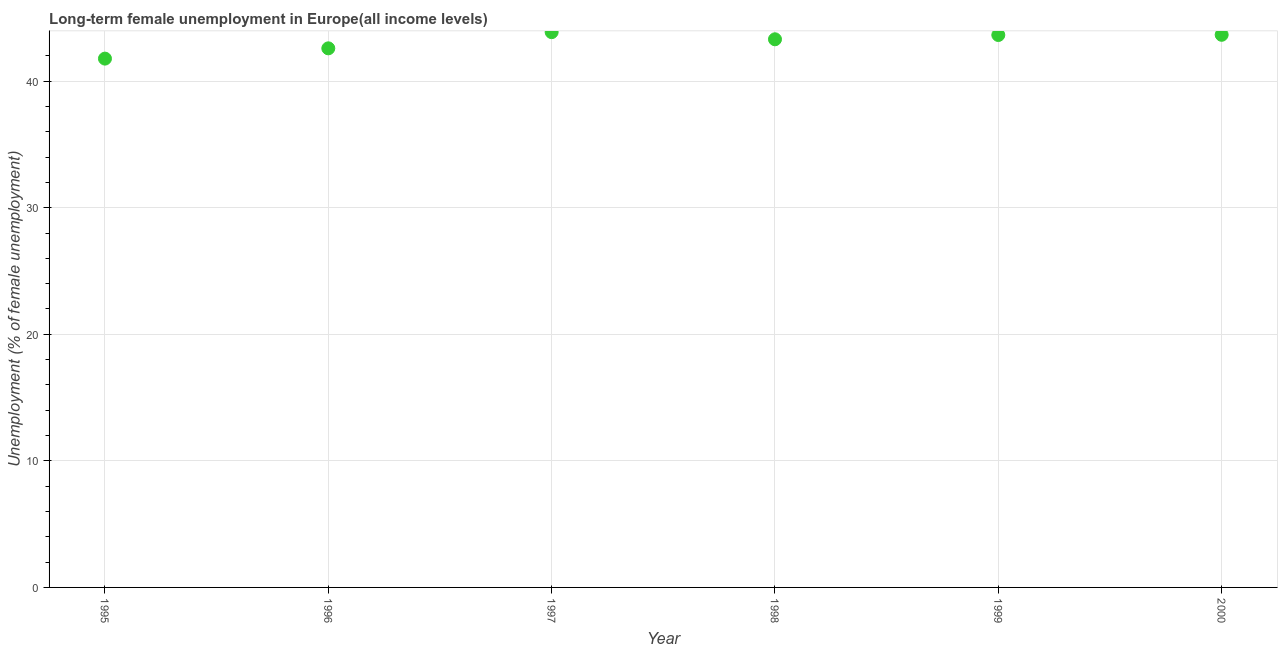What is the long-term female unemployment in 1995?
Offer a very short reply. 41.78. Across all years, what is the maximum long-term female unemployment?
Make the answer very short. 43.87. Across all years, what is the minimum long-term female unemployment?
Provide a short and direct response. 41.78. In which year was the long-term female unemployment minimum?
Your response must be concise. 1995. What is the sum of the long-term female unemployment?
Make the answer very short. 258.86. What is the difference between the long-term female unemployment in 1997 and 1998?
Your answer should be compact. 0.56. What is the average long-term female unemployment per year?
Keep it short and to the point. 43.14. What is the median long-term female unemployment?
Ensure brevity in your answer.  43.48. In how many years, is the long-term female unemployment greater than 24 %?
Provide a succinct answer. 6. What is the ratio of the long-term female unemployment in 1995 to that in 1999?
Make the answer very short. 0.96. What is the difference between the highest and the second highest long-term female unemployment?
Provide a succinct answer. 0.21. What is the difference between the highest and the lowest long-term female unemployment?
Your answer should be very brief. 2.09. How many dotlines are there?
Provide a short and direct response. 1. Are the values on the major ticks of Y-axis written in scientific E-notation?
Provide a short and direct response. No. Does the graph contain grids?
Your answer should be compact. Yes. What is the title of the graph?
Make the answer very short. Long-term female unemployment in Europe(all income levels). What is the label or title of the X-axis?
Offer a very short reply. Year. What is the label or title of the Y-axis?
Your response must be concise. Unemployment (% of female unemployment). What is the Unemployment (% of female unemployment) in 1995?
Your answer should be compact. 41.78. What is the Unemployment (% of female unemployment) in 1996?
Make the answer very short. 42.59. What is the Unemployment (% of female unemployment) in 1997?
Make the answer very short. 43.87. What is the Unemployment (% of female unemployment) in 1998?
Your response must be concise. 43.31. What is the Unemployment (% of female unemployment) in 1999?
Ensure brevity in your answer.  43.65. What is the Unemployment (% of female unemployment) in 2000?
Offer a terse response. 43.66. What is the difference between the Unemployment (% of female unemployment) in 1995 and 1996?
Keep it short and to the point. -0.81. What is the difference between the Unemployment (% of female unemployment) in 1995 and 1997?
Keep it short and to the point. -2.09. What is the difference between the Unemployment (% of female unemployment) in 1995 and 1998?
Your answer should be very brief. -1.53. What is the difference between the Unemployment (% of female unemployment) in 1995 and 1999?
Keep it short and to the point. -1.87. What is the difference between the Unemployment (% of female unemployment) in 1995 and 2000?
Keep it short and to the point. -1.88. What is the difference between the Unemployment (% of female unemployment) in 1996 and 1997?
Your answer should be compact. -1.28. What is the difference between the Unemployment (% of female unemployment) in 1996 and 1998?
Keep it short and to the point. -0.72. What is the difference between the Unemployment (% of female unemployment) in 1996 and 1999?
Your response must be concise. -1.05. What is the difference between the Unemployment (% of female unemployment) in 1996 and 2000?
Keep it short and to the point. -1.07. What is the difference between the Unemployment (% of female unemployment) in 1997 and 1998?
Provide a succinct answer. 0.56. What is the difference between the Unemployment (% of female unemployment) in 1997 and 1999?
Make the answer very short. 0.23. What is the difference between the Unemployment (% of female unemployment) in 1997 and 2000?
Offer a terse response. 0.21. What is the difference between the Unemployment (% of female unemployment) in 1998 and 1999?
Make the answer very short. -0.34. What is the difference between the Unemployment (% of female unemployment) in 1998 and 2000?
Your answer should be compact. -0.35. What is the difference between the Unemployment (% of female unemployment) in 1999 and 2000?
Your answer should be compact. -0.02. What is the ratio of the Unemployment (% of female unemployment) in 1995 to that in 1996?
Give a very brief answer. 0.98. What is the ratio of the Unemployment (% of female unemployment) in 1995 to that in 1999?
Provide a short and direct response. 0.96. What is the ratio of the Unemployment (% of female unemployment) in 1996 to that in 1999?
Ensure brevity in your answer.  0.98. What is the ratio of the Unemployment (% of female unemployment) in 1997 to that in 2000?
Provide a succinct answer. 1. What is the ratio of the Unemployment (% of female unemployment) in 1998 to that in 2000?
Your answer should be compact. 0.99. What is the ratio of the Unemployment (% of female unemployment) in 1999 to that in 2000?
Keep it short and to the point. 1. 